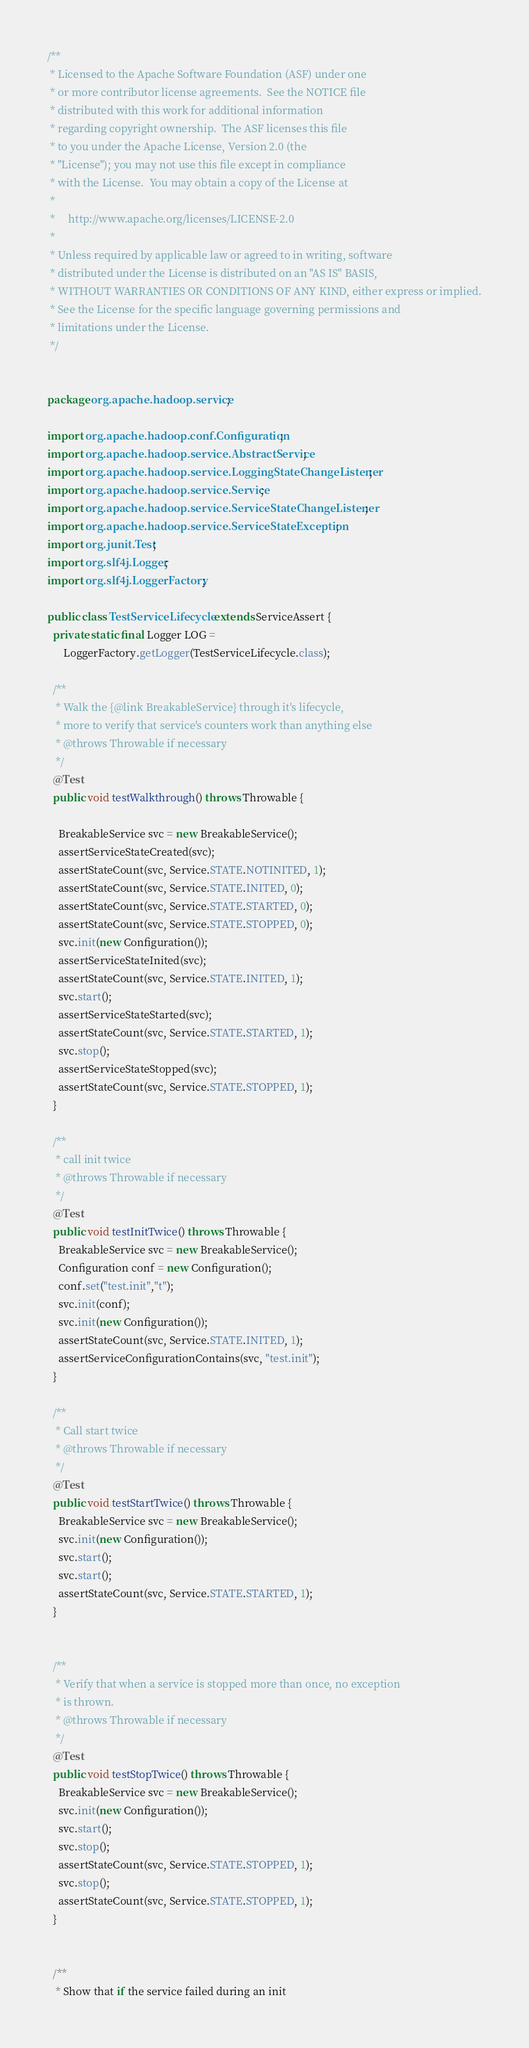<code> <loc_0><loc_0><loc_500><loc_500><_Java_>/**
 * Licensed to the Apache Software Foundation (ASF) under one
 * or more contributor license agreements.  See the NOTICE file
 * distributed with this work for additional information
 * regarding copyright ownership.  The ASF licenses this file
 * to you under the Apache License, Version 2.0 (the
 * "License"); you may not use this file except in compliance
 * with the License.  You may obtain a copy of the License at
 *
 *     http://www.apache.org/licenses/LICENSE-2.0
 *
 * Unless required by applicable law or agreed to in writing, software
 * distributed under the License is distributed on an "AS IS" BASIS,
 * WITHOUT WARRANTIES OR CONDITIONS OF ANY KIND, either express or implied.
 * See the License for the specific language governing permissions and
 * limitations under the License.
 */


package org.apache.hadoop.service;

import org.apache.hadoop.conf.Configuration;
import org.apache.hadoop.service.AbstractService;
import org.apache.hadoop.service.LoggingStateChangeListener;
import org.apache.hadoop.service.Service;
import org.apache.hadoop.service.ServiceStateChangeListener;
import org.apache.hadoop.service.ServiceStateException;
import org.junit.Test;
import org.slf4j.Logger;
import org.slf4j.LoggerFactory;

public class TestServiceLifecycle extends ServiceAssert {
  private static final Logger LOG =
      LoggerFactory.getLogger(TestServiceLifecycle.class);

  /**
   * Walk the {@link BreakableService} through it's lifecycle, 
   * more to verify that service's counters work than anything else
   * @throws Throwable if necessary
   */
  @Test
  public void testWalkthrough() throws Throwable {

    BreakableService svc = new BreakableService();
    assertServiceStateCreated(svc);
    assertStateCount(svc, Service.STATE.NOTINITED, 1);
    assertStateCount(svc, Service.STATE.INITED, 0);
    assertStateCount(svc, Service.STATE.STARTED, 0);
    assertStateCount(svc, Service.STATE.STOPPED, 0);
    svc.init(new Configuration());
    assertServiceStateInited(svc);
    assertStateCount(svc, Service.STATE.INITED, 1);
    svc.start();
    assertServiceStateStarted(svc);
    assertStateCount(svc, Service.STATE.STARTED, 1);
    svc.stop();
    assertServiceStateStopped(svc);
    assertStateCount(svc, Service.STATE.STOPPED, 1);
  }

  /**
   * call init twice
   * @throws Throwable if necessary
   */
  @Test
  public void testInitTwice() throws Throwable {
    BreakableService svc = new BreakableService();
    Configuration conf = new Configuration();
    conf.set("test.init","t");
    svc.init(conf);
    svc.init(new Configuration());
    assertStateCount(svc, Service.STATE.INITED, 1);
    assertServiceConfigurationContains(svc, "test.init");
  }

  /**
   * Call start twice
   * @throws Throwable if necessary
   */
  @Test
  public void testStartTwice() throws Throwable {
    BreakableService svc = new BreakableService();
    svc.init(new Configuration());
    svc.start();
    svc.start();
    assertStateCount(svc, Service.STATE.STARTED, 1);
  }


  /**
   * Verify that when a service is stopped more than once, no exception
   * is thrown.
   * @throws Throwable if necessary
   */
  @Test
  public void testStopTwice() throws Throwable {
    BreakableService svc = new BreakableService();
    svc.init(new Configuration());
    svc.start();
    svc.stop();
    assertStateCount(svc, Service.STATE.STOPPED, 1);
    svc.stop();
    assertStateCount(svc, Service.STATE.STOPPED, 1);
  }


  /**
   * Show that if the service failed during an init</code> 